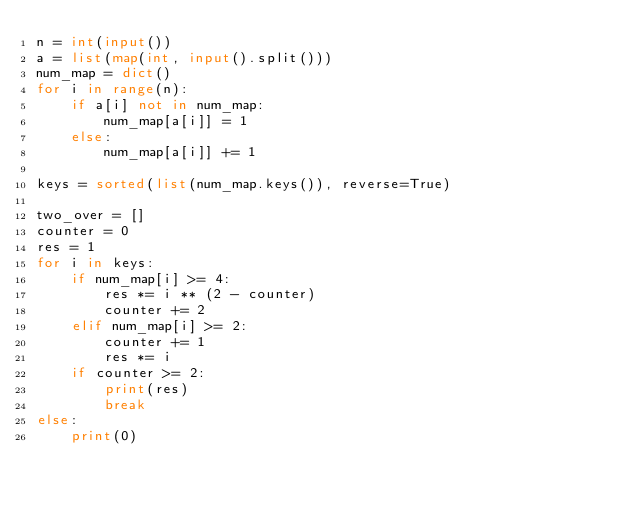Convert code to text. <code><loc_0><loc_0><loc_500><loc_500><_Python_>n = int(input())
a = list(map(int, input().split()))
num_map = dict()
for i in range(n):
    if a[i] not in num_map:
        num_map[a[i]] = 1
    else:
        num_map[a[i]] += 1

keys = sorted(list(num_map.keys()), reverse=True)

two_over = []
counter = 0
res = 1
for i in keys:
    if num_map[i] >= 4:
        res *= i ** (2 - counter)
        counter += 2
    elif num_map[i] >= 2:
        counter += 1
        res *= i
    if counter >= 2:
        print(res)
        break
else:
    print(0)
</code> 